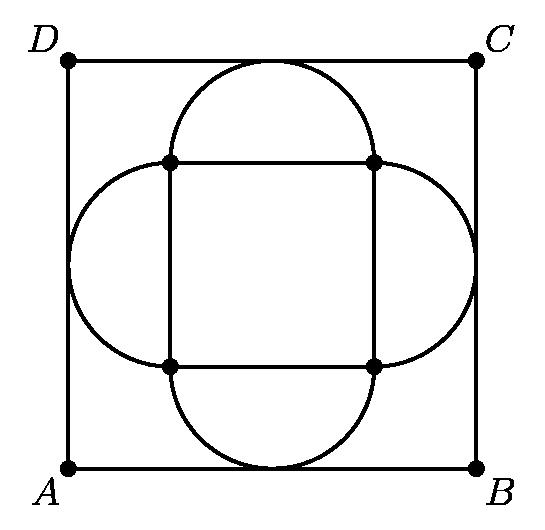What happens to the area of the inner square $ABCD$ if the size of the outer square changes? The area of the inner square $ABCD$ is functionally dependent on the size of the outer square. Since the side length of $ABCD$ is calculated by the expression involving the side length of the outer square, $s * (√2 - 1)$, it follows that any change in the size of the outer square will be reflected in the area of $ABCD$. Specifically, as the size of the outer square increases or decreases, the area of $ABCD$ will increase or decrease proportionally to the square of the side length of the outer square. 